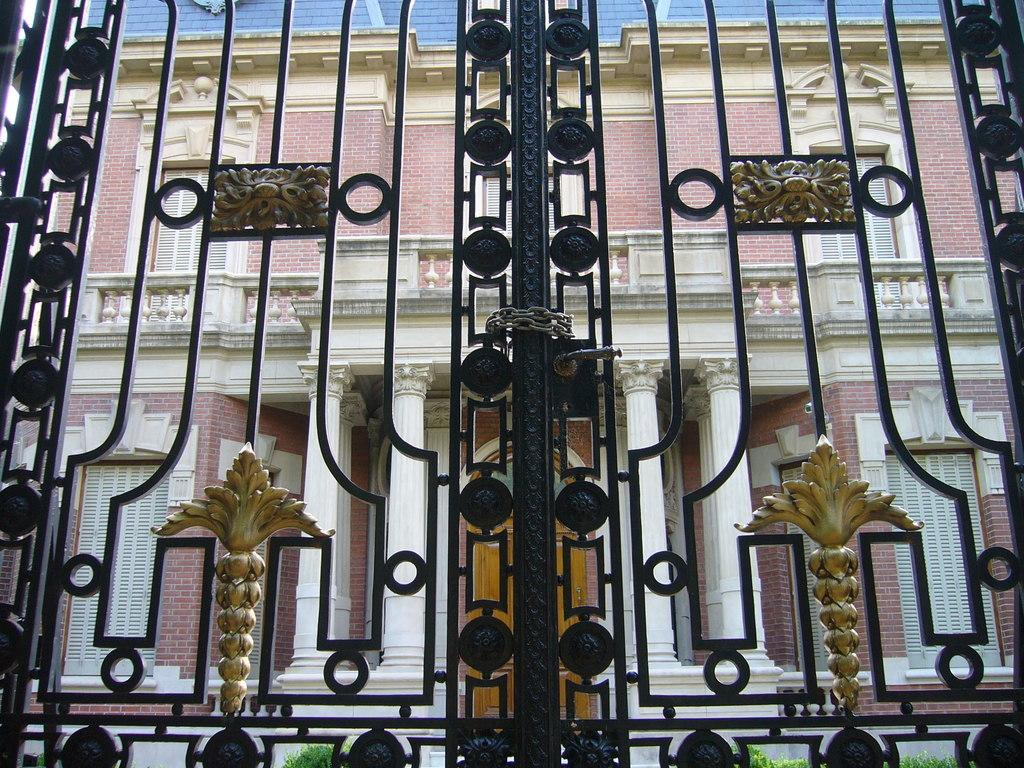What is the main subject in the foreground of the image? There is a black color gate in the foreground of the image. What can be seen in the background of the image? There is a building in the background of the image. How many pizzas are being held by the muscle in the fiction book in the image? There are no pizzas, muscles, or fiction books present in the image. 